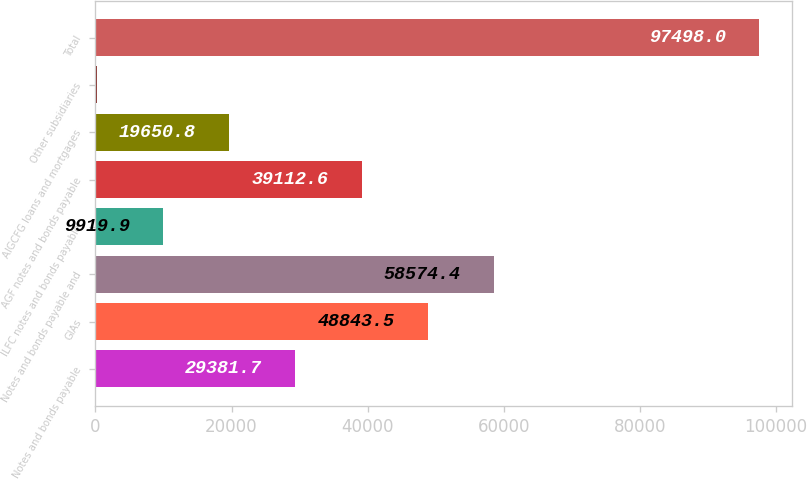Convert chart to OTSL. <chart><loc_0><loc_0><loc_500><loc_500><bar_chart><fcel>Notes and bonds payable<fcel>GIAs<fcel>Notes and bonds payable and<fcel>ILFC notes and bonds payable<fcel>AGF notes and bonds payable<fcel>AIGCFG loans and mortgages<fcel>Other subsidiaries<fcel>Total<nl><fcel>29381.7<fcel>48843.5<fcel>58574.4<fcel>9919.9<fcel>39112.6<fcel>19650.8<fcel>189<fcel>97498<nl></chart> 